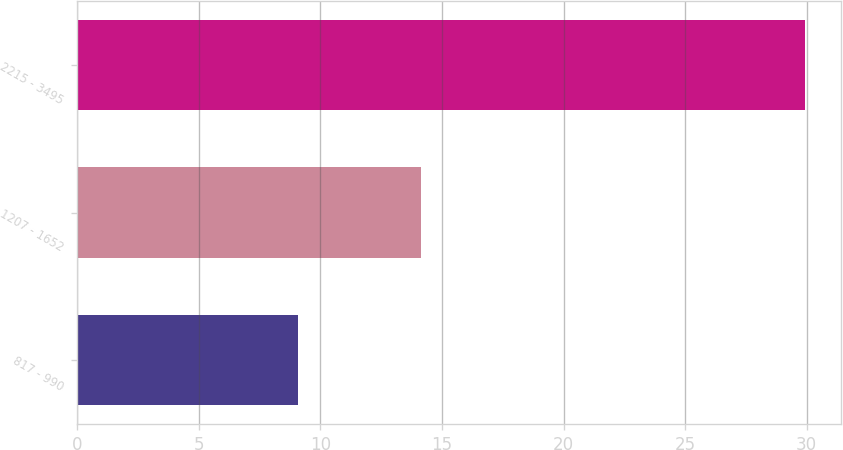Convert chart. <chart><loc_0><loc_0><loc_500><loc_500><bar_chart><fcel>817 - 990<fcel>1207 - 1652<fcel>2215 - 3495<nl><fcel>9.09<fcel>14.14<fcel>29.92<nl></chart> 